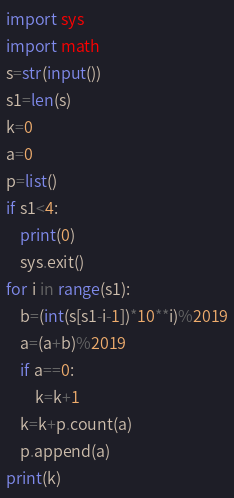Convert code to text. <code><loc_0><loc_0><loc_500><loc_500><_Python_>import sys
import math
s=str(input())
s1=len(s)
k=0
a=0
p=list()
if s1<4:
    print(0)
    sys.exit()
for i in range(s1):
    b=(int(s[s1-i-1])*10**i)%2019
    a=(a+b)%2019
    if a==0:
        k=k+1
    k=k+p.count(a)
    p.append(a)
print(k)</code> 